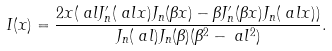Convert formula to latex. <formula><loc_0><loc_0><loc_500><loc_500>I ( x ) & = \frac { 2 x ( \ a l J _ { n } ^ { \prime } ( \ a l x ) J _ { n } ( \beta x ) - \beta J _ { n } ^ { \prime } ( \beta x ) J _ { n } ( \ a l x ) ) } { J _ { n } ( \ a l ) J _ { n } ( \beta ) ( \beta ^ { 2 } - \ a l ^ { 2 } ) } .</formula> 